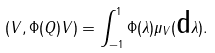Convert formula to latex. <formula><loc_0><loc_0><loc_500><loc_500>\left ( V , \Phi ( Q ) V \right ) = \int _ { - 1 } ^ { 1 } \Phi ( \lambda ) \mu _ { V } ( \text  d \lambda).</formula> 